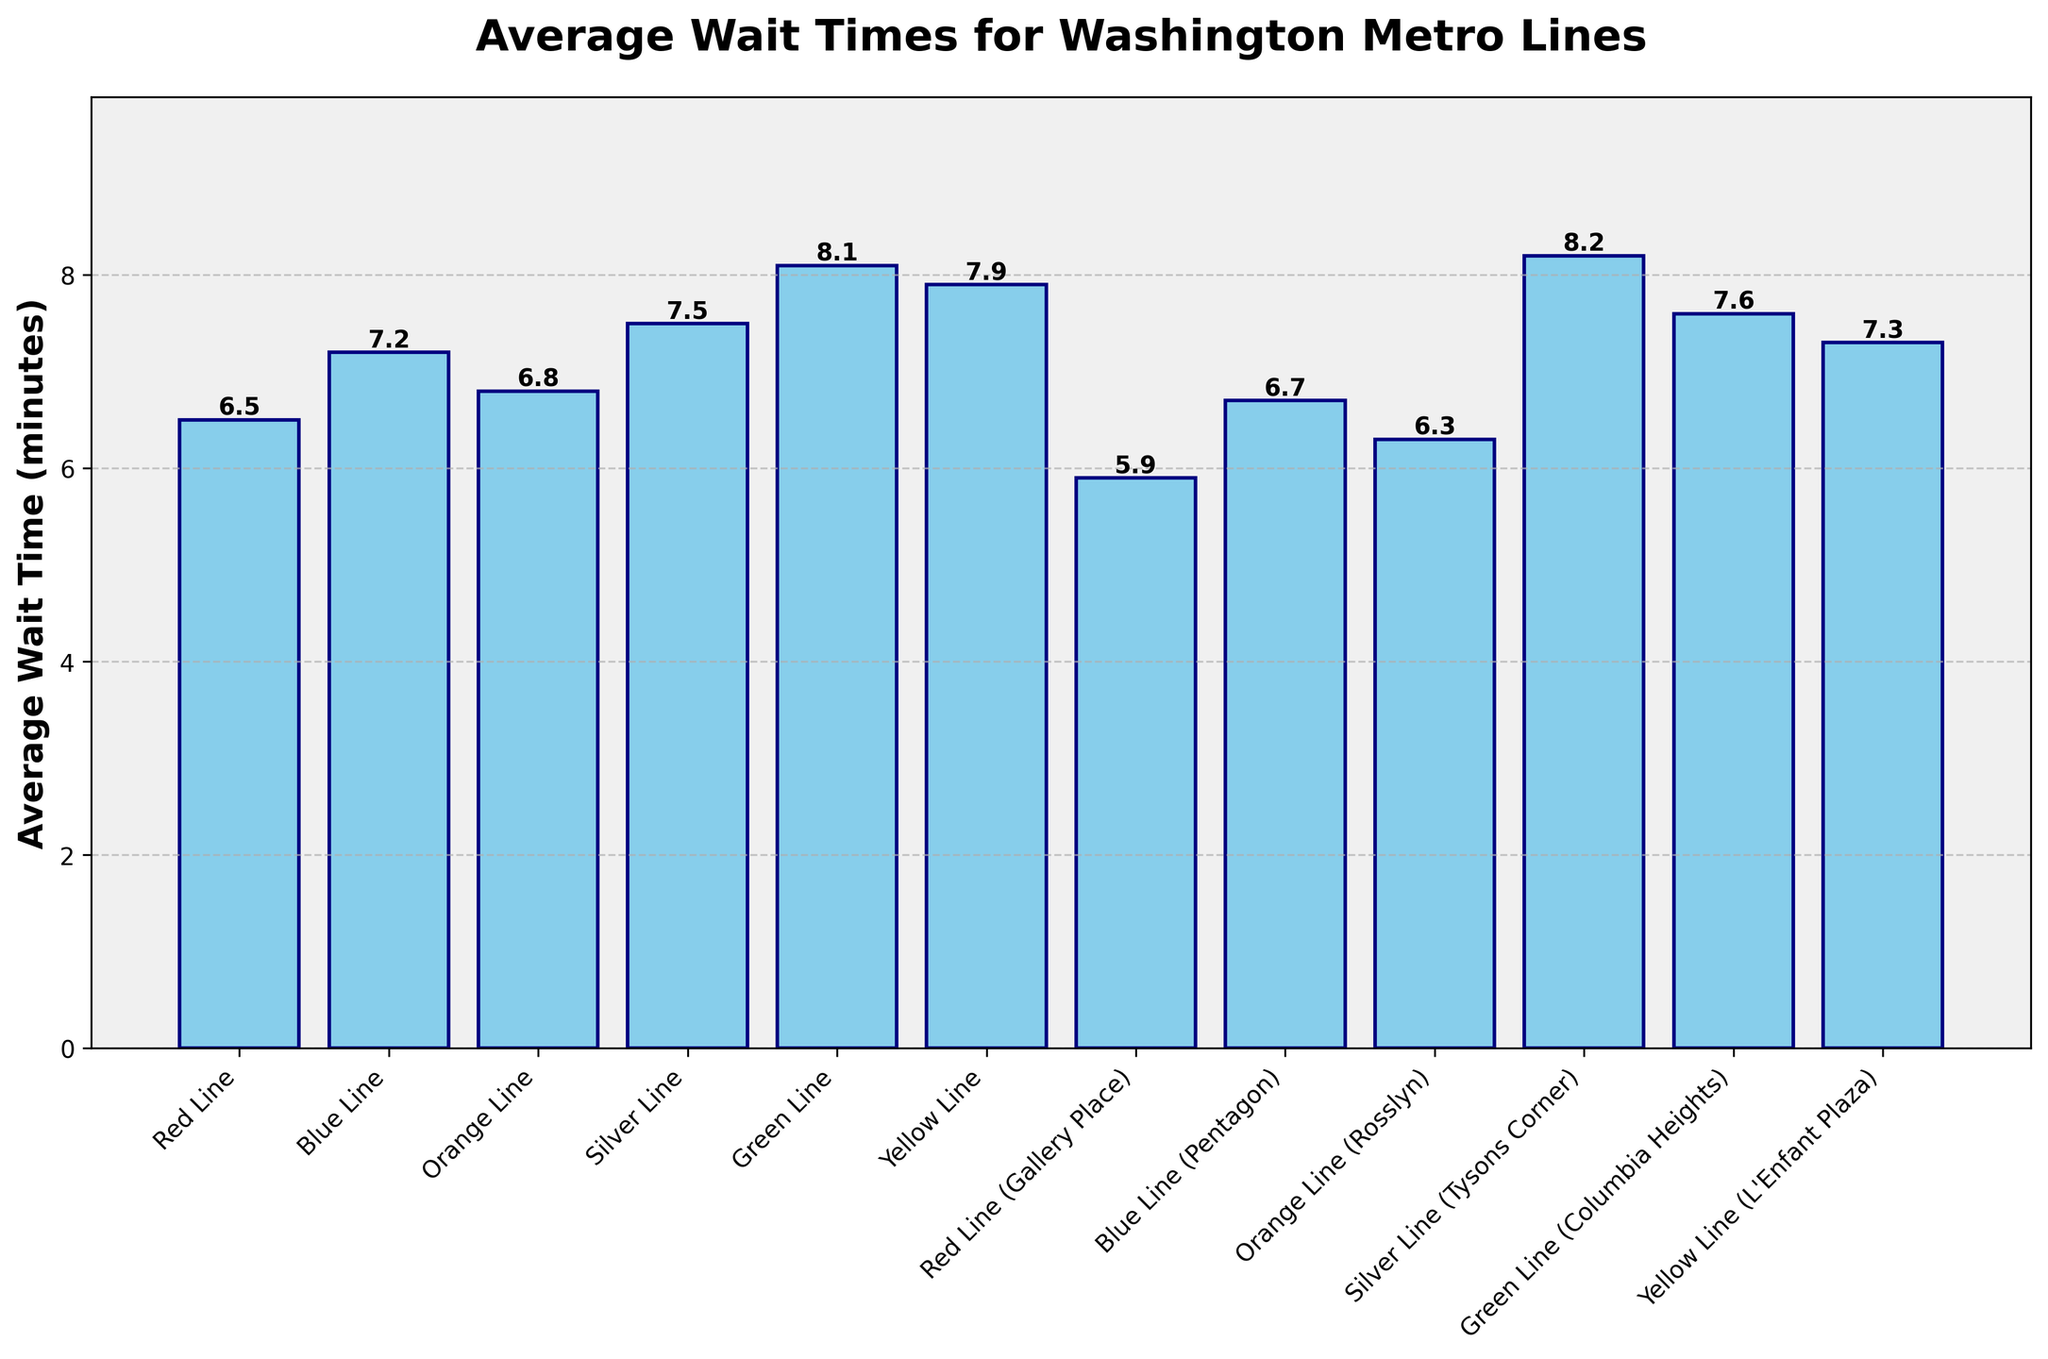Which Metro line has the longest average wait time? The Green Line has the longest average wait time because its bar is the tallest among all the bars shown in the chart, reaching 8.1 minutes.
Answer: Green Line What's the average wait time difference between the Red Line and the Silver Line? The Red Line has an average wait time of 6.5 minutes, and the Silver Line has an average wait time of 7.5 minutes. To find the difference, subtract 6.5 from 7.5, which gives 1.0 minute.
Answer: 1.0 minute Which Metro lines have an average wait time less than 7 minutes? By inspecting the chart, the Metro lines with average wait times less than 7 minutes are the Red Line (6.5 minutes), Red Line (Gallery Place) (5.9 minutes), and Orange Line (Rosslyn) (6.3 minutes).
Answer: Red Line, Red Line (Gallery Place), Orange Line (Rosslyn) How much greater is the average wait time for the Yellow Line compared to the Green Line (Columbia Heights)? The average wait time for the Yellow Line is 7.9 minutes, while the wait time for the Green Line (Columbia Heights) is 7.6 minutes. Subtracting 7.6 from 7.9 gives a difference of 0.3 minutes.
Answer: 0.3 minutes Rank the Metro lines in descending order of average wait times. By examining the heights of the bars from highest to lowest, the ranking is as follows: Silver Line (Tysons Corner), Green Line, Yellow Line, Green Line (Columbia Heights), Silver Line, Yellow Line (L'Enfant Plaza), Blue Line, Orange Line, Blue Line (Pentagon), Orange Line (Rosslyn), Red Line, Red Line (Gallery Place).
Answer: Silver Line (Tysons Corner), Green Line, Yellow Line, Green Line (Columbia Heights), Silver Line, Yellow Line (L'Enfant Plaza), Blue Line, Orange Line, Blue Line (Pentagon), Orange Line (Rosslyn), Red Line, Red Line (Gallery Place) What is the median average wait time among all Metro lines? List all the wait times in order: 5.9, 6.3, 6.5, 6.7, 6.8, 7.2, 7.3, 7.5, 7.6, 7.9, 8.1, 8.2. With 12 data points, the median is the average of the 6th and 7th values. (6.8 + 7.2) / 2 = 7.0 minutes.
Answer: 7.0 minutes Which Metro line serves the busiest areas (like major stations) and has the shortest average wait time? The Red Line (Gallery Place) has the shortest average wait time of 5.9 minutes among the Metro lines serving major stations like Gallery Place.
Answer: Red Line (Gallery Place) 